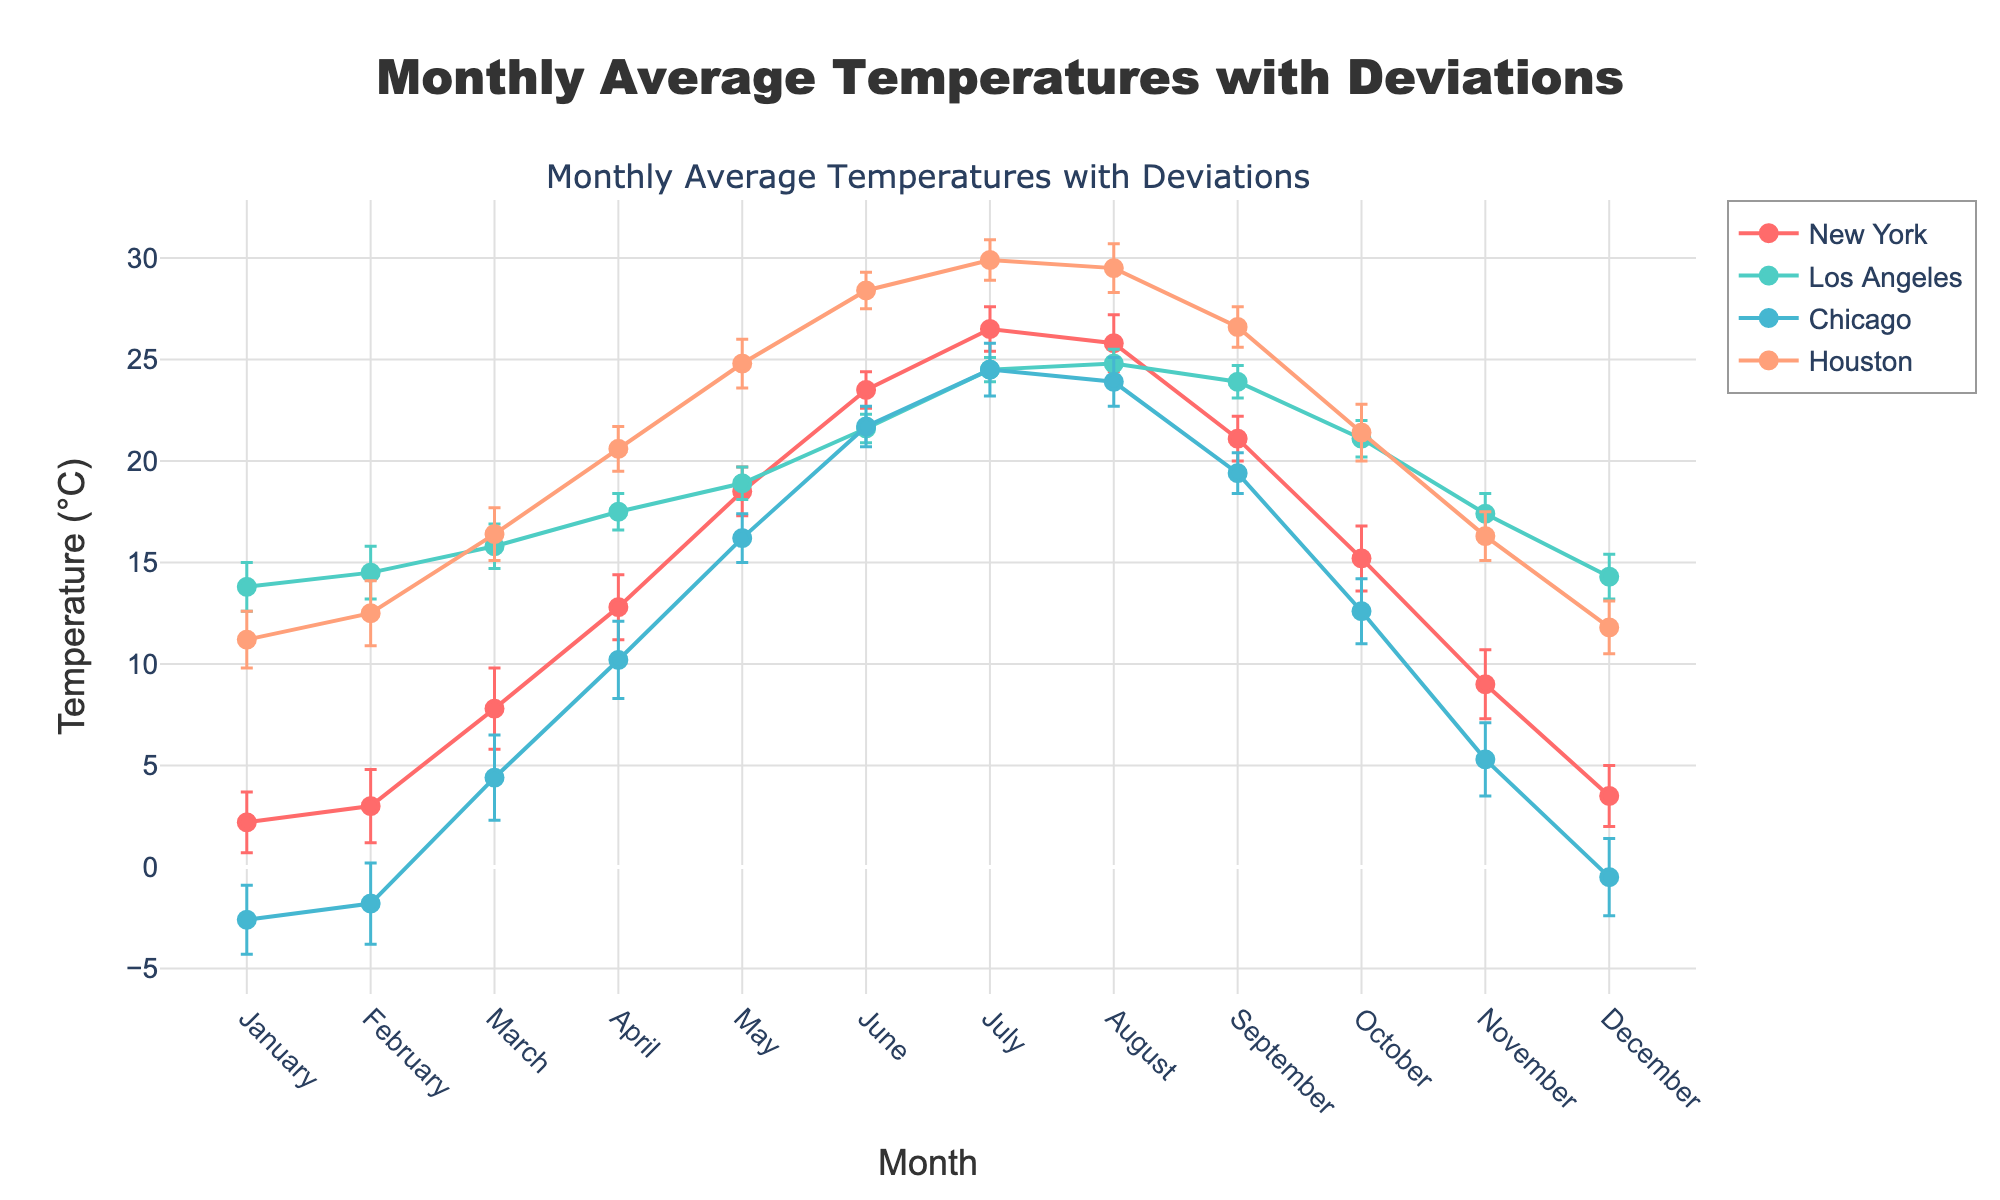What is the title of the figure? The title is usually located at the top of the figure. Here, it reads "Monthly Average Temperatures with Deviations."
Answer: Monthly Average Temperatures with Deviations How many cities are included in the figure? By looking at the legend or the different lines and markers in the plot, you can count the number of cities represented. Four cities are shown: New York, Los Angeles, Chicago, and Houston.
Answer: Four Which city has the highest average temperature in July? Check the line or marker corresponding to each city for July and identify the highest y-value, representing the temperature. Houston has the highest average temperature in July at 29.9°C.
Answer: Houston What is the average temperature in New York in March? By tracing the line for New York to the point for March, you can find that the average temperature is 7.8°C.
Answer: 7.8°C Which month shows the largest deviation for Chicago? You can examine the error bars for Chicago and identify the month with the largest error, which is February with a deviation of 2.0°C.
Answer: February What are the trends in average temperature across the year for Los Angeles? Observe the line for Los Angeles. It generally increases from January to August, peaks around July/August, and then decreases towards December.
Answer: Increases, peaks in July/August, then decreases Which city experiences the coldest month of the year? Look at all the lines and identify the lowest point on the y-axis. Chicago in January has the lowest average temperature at -2.6°C.
Answer: Chicago Compare the average temperatures in October for all four cities. By checking the October points for each city line: New York (15.2°C), Los Angeles (21.1°C), Chicago (12.6°C), and Houston (21.4°C).
Answer: 15.2°C (New York), 21.1°C (Los Angeles), 12.6°C (Chicago), 21.4°C (Houston) Which city shows the smallest fluctuation in temperature throughout the year? Evaluate the range of temperatures each city exhibits. Los Angeles shows the smallest fluctuation, going from 13.8°C in January to 24.8°C in August.
Answer: Los Angeles 